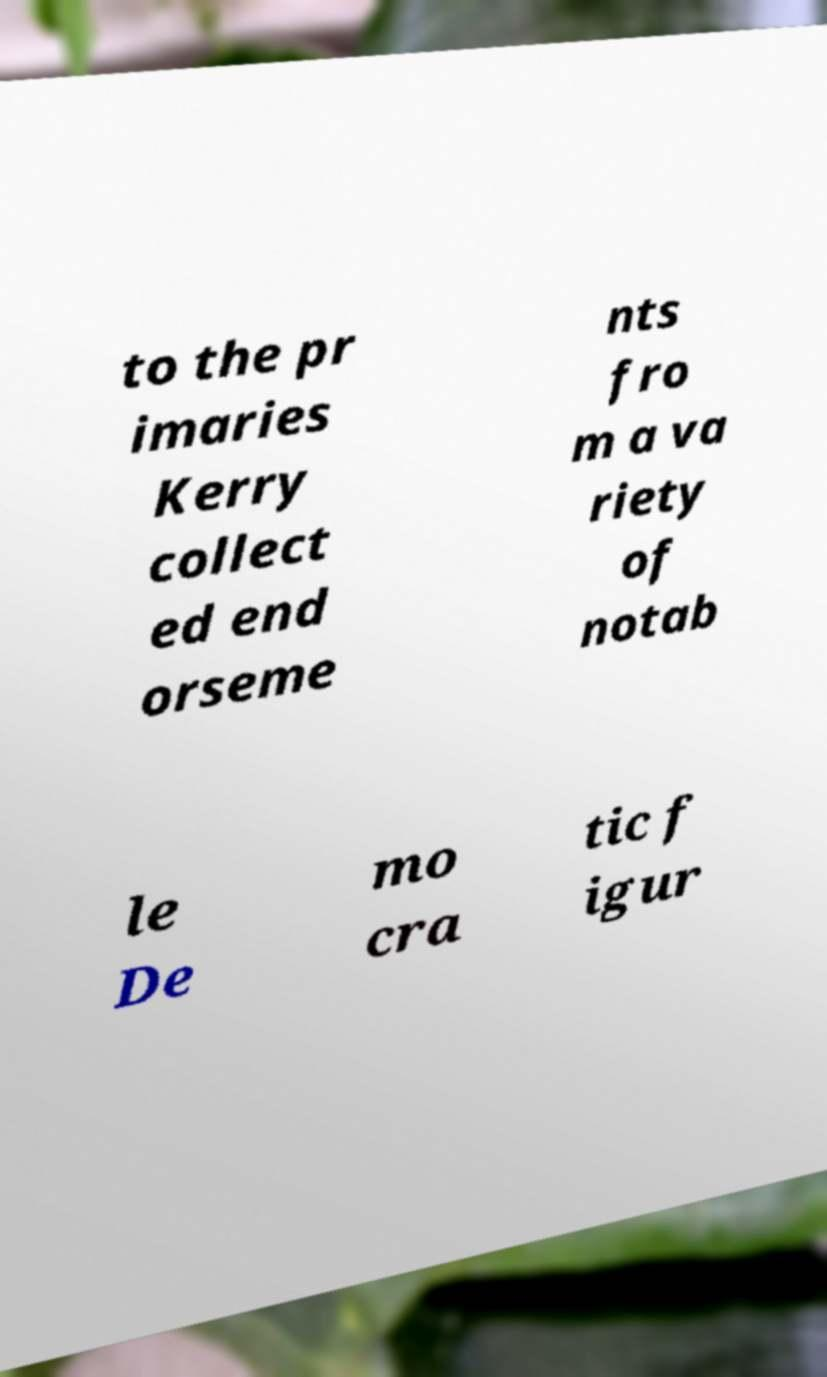There's text embedded in this image that I need extracted. Can you transcribe it verbatim? to the pr imaries Kerry collect ed end orseme nts fro m a va riety of notab le De mo cra tic f igur 